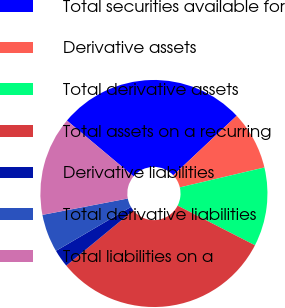Convert chart. <chart><loc_0><loc_0><loc_500><loc_500><pie_chart><fcel>Total securities available for<fcel>Derivative assets<fcel>Total derivative assets<fcel>Total assets on a recurring<fcel>Derivative liabilities<fcel>Total derivative liabilities<fcel>Total liabilities on a<nl><fcel>26.9%<fcel>8.32%<fcel>11.22%<fcel>31.51%<fcel>2.52%<fcel>5.42%<fcel>14.12%<nl></chart> 